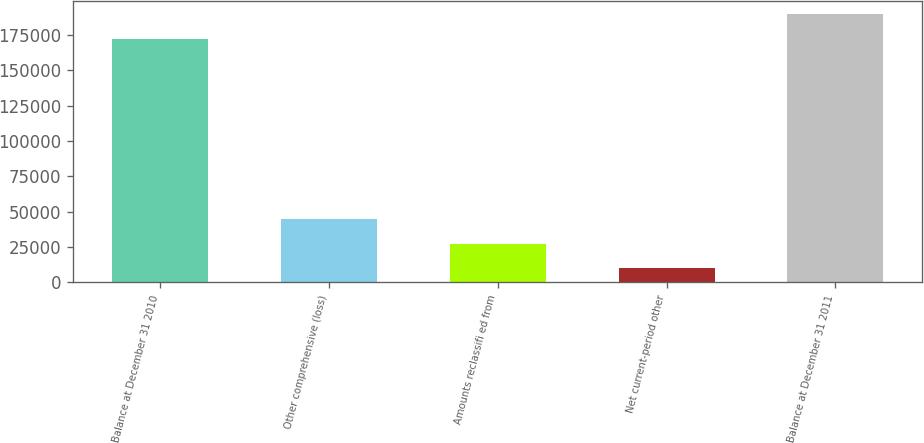Convert chart. <chart><loc_0><loc_0><loc_500><loc_500><bar_chart><fcel>Balance at December 31 2010<fcel>Other comprehensive (loss)<fcel>Amounts reclassifi ed from<fcel>Net current-period other<fcel>Balance at December 31 2011<nl><fcel>172396<fcel>44585.2<fcel>27345.6<fcel>10106<fcel>189636<nl></chart> 